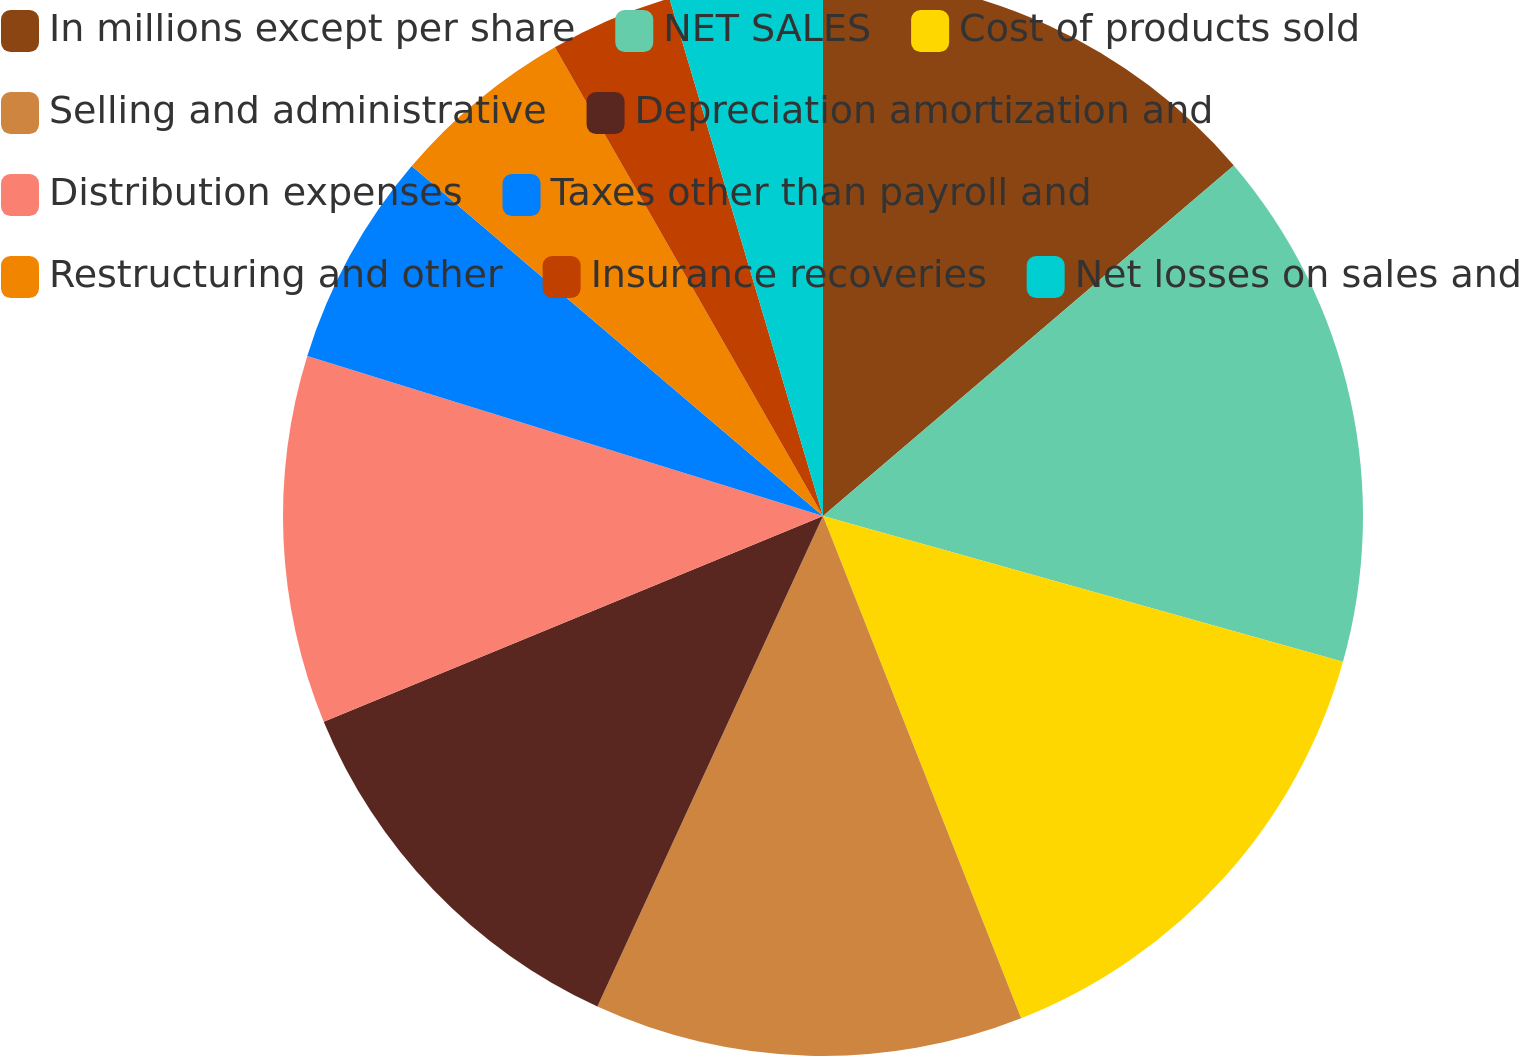Convert chart. <chart><loc_0><loc_0><loc_500><loc_500><pie_chart><fcel>In millions except per share<fcel>NET SALES<fcel>Cost of products sold<fcel>Selling and administrative<fcel>Depreciation amortization and<fcel>Distribution expenses<fcel>Taxes other than payroll and<fcel>Restructuring and other<fcel>Insurance recoveries<fcel>Net losses on sales and<nl><fcel>13.76%<fcel>15.59%<fcel>14.67%<fcel>12.84%<fcel>11.92%<fcel>11.01%<fcel>6.43%<fcel>5.51%<fcel>3.68%<fcel>4.59%<nl></chart> 